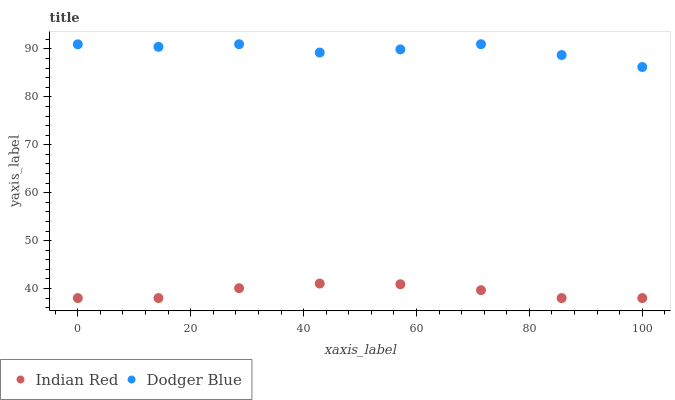Does Indian Red have the minimum area under the curve?
Answer yes or no. Yes. Does Dodger Blue have the maximum area under the curve?
Answer yes or no. Yes. Does Indian Red have the maximum area under the curve?
Answer yes or no. No. Is Indian Red the smoothest?
Answer yes or no. Yes. Is Dodger Blue the roughest?
Answer yes or no. Yes. Is Indian Red the roughest?
Answer yes or no. No. Does Indian Red have the lowest value?
Answer yes or no. Yes. Does Dodger Blue have the highest value?
Answer yes or no. Yes. Does Indian Red have the highest value?
Answer yes or no. No. Is Indian Red less than Dodger Blue?
Answer yes or no. Yes. Is Dodger Blue greater than Indian Red?
Answer yes or no. Yes. Does Indian Red intersect Dodger Blue?
Answer yes or no. No. 